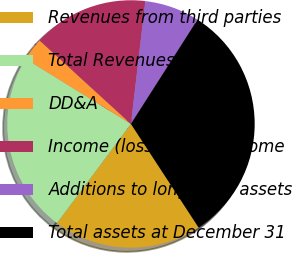Convert chart. <chart><loc_0><loc_0><loc_500><loc_500><pie_chart><fcel>Revenues from third parties<fcel>Total Revenues<fcel>DD&A<fcel>Income (loss) before income<fcel>Additions to long-lived assets<fcel>Total assets at December 31<nl><fcel>19.4%<fcel>23.62%<fcel>2.97%<fcel>15.07%<fcel>7.19%<fcel>31.75%<nl></chart> 